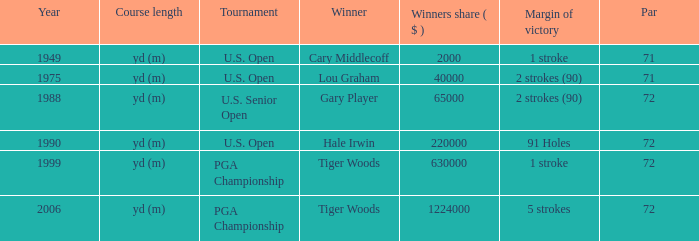I'm looking to parse the entire table for insights. Could you assist me with that? {'header': ['Year', 'Course length', 'Tournament', 'Winner', 'Winners share ( $ )', 'Margin of victory', 'Par'], 'rows': [['1949', 'yd (m)', 'U.S. Open', 'Cary Middlecoff', '2000', '1 stroke', '71'], ['1975', 'yd (m)', 'U.S. Open', 'Lou Graham', '40000', '2 strokes (90)', '71'], ['1988', 'yd (m)', 'U.S. Senior Open', 'Gary Player', '65000', '2 strokes (90)', '72'], ['1990', 'yd (m)', 'U.S. Open', 'Hale Irwin', '220000', '91 Holes', '72'], ['1999', 'yd (m)', 'PGA Championship', 'Tiger Woods', '630000', '1 stroke', '72'], ['2006', 'yd (m)', 'PGA Championship', 'Tiger Woods', '1224000', '5 strokes', '72']]} When hale irwin is the winner what is the margin of victory? 91 Holes. 